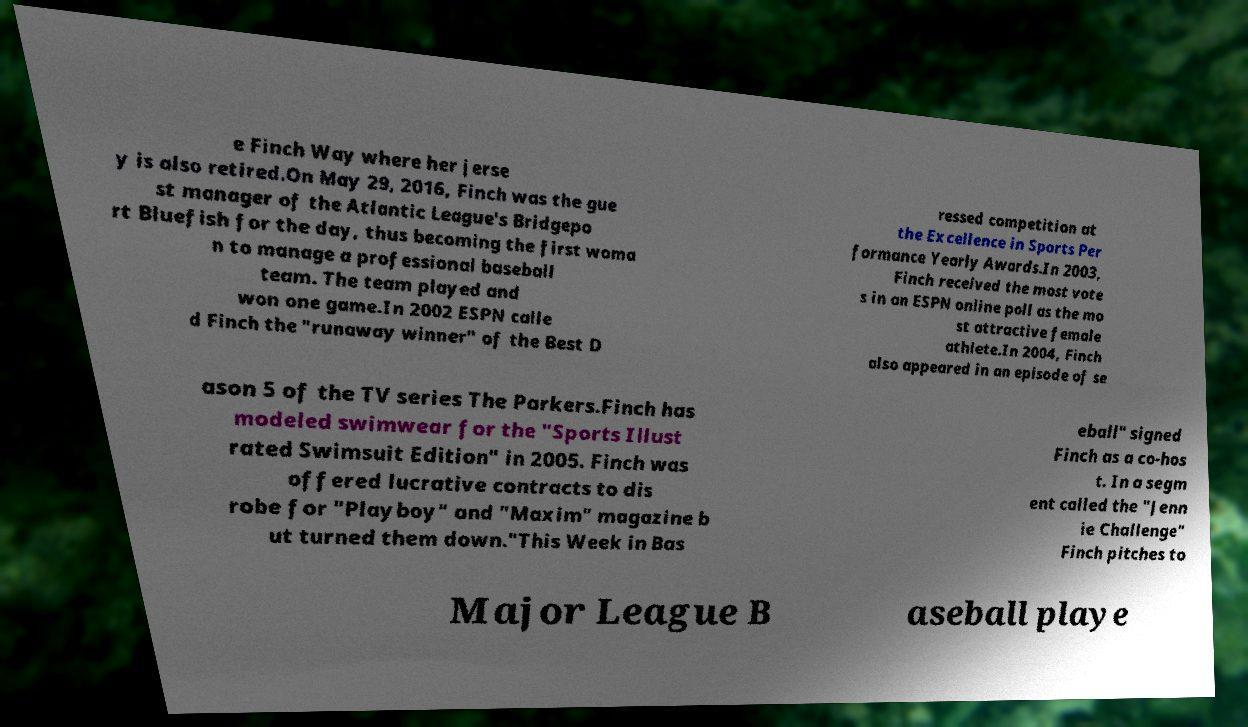There's text embedded in this image that I need extracted. Can you transcribe it verbatim? e Finch Way where her jerse y is also retired.On May 29, 2016, Finch was the gue st manager of the Atlantic League's Bridgepo rt Bluefish for the day, thus becoming the first woma n to manage a professional baseball team. The team played and won one game.In 2002 ESPN calle d Finch the "runaway winner" of the Best D ressed competition at the Excellence in Sports Per formance Yearly Awards.In 2003, Finch received the most vote s in an ESPN online poll as the mo st attractive female athlete.In 2004, Finch also appeared in an episode of se ason 5 of the TV series The Parkers.Finch has modeled swimwear for the "Sports Illust rated Swimsuit Edition" in 2005. Finch was offered lucrative contracts to dis robe for "Playboy" and "Maxim" magazine b ut turned them down."This Week in Bas eball" signed Finch as a co-hos t. In a segm ent called the "Jenn ie Challenge" Finch pitches to Major League B aseball playe 